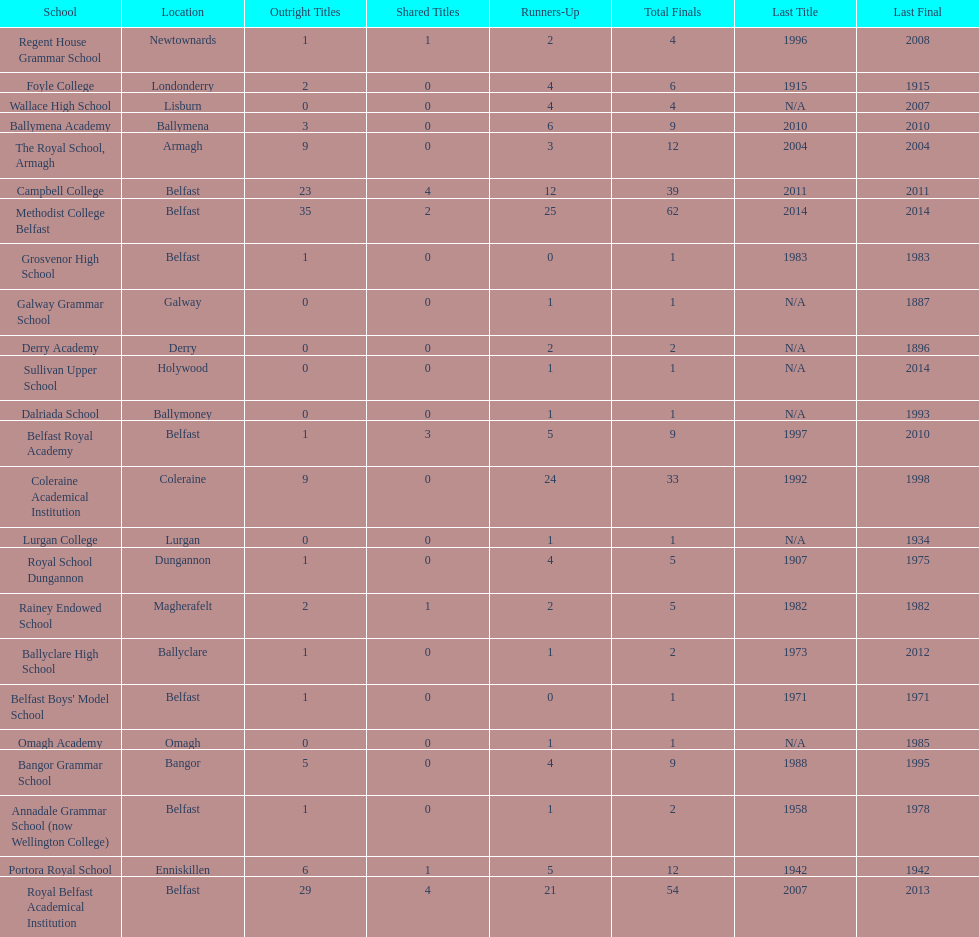Who has the most recent title win, campbell college or regent house grammar school? Campbell College. 